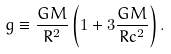<formula> <loc_0><loc_0><loc_500><loc_500>g \equiv \frac { G M } { R ^ { 2 } } \left ( 1 + 3 \frac { G M } { R c ^ { 2 } } \right ) .</formula> 